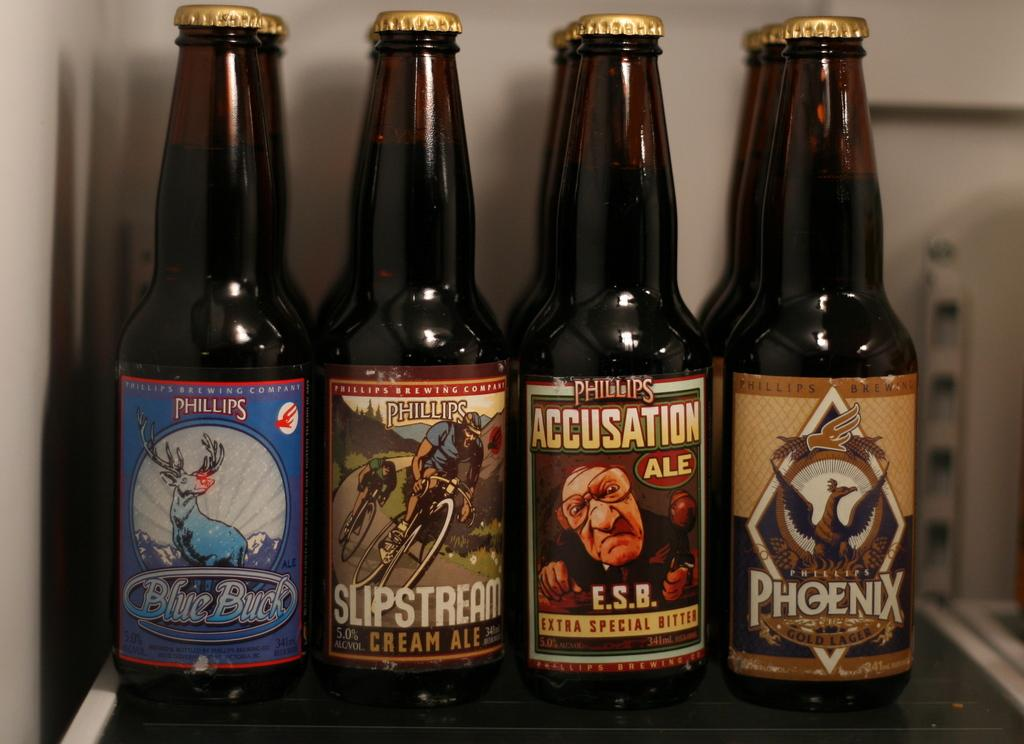<image>
Provide a brief description of the given image. A bottle of Phillips Blue Buck is next to a bottle of Slipstream. 